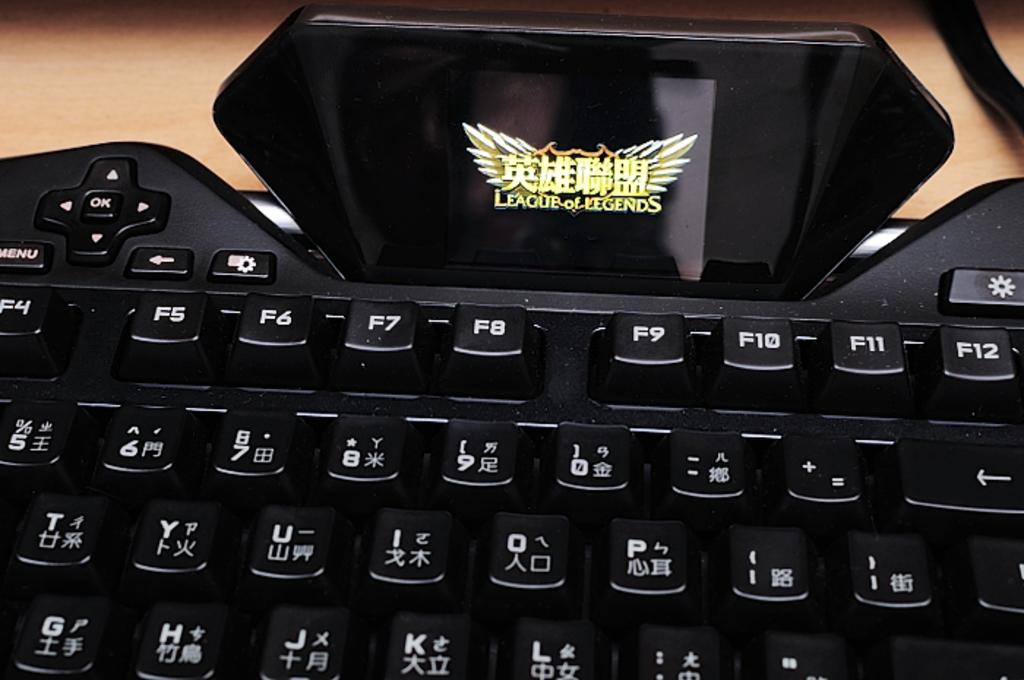Provide a one-sentence caption for the provided image. A close up of a keyboard with Roman and Chinese characters and a "League of Legends" placard on top. 